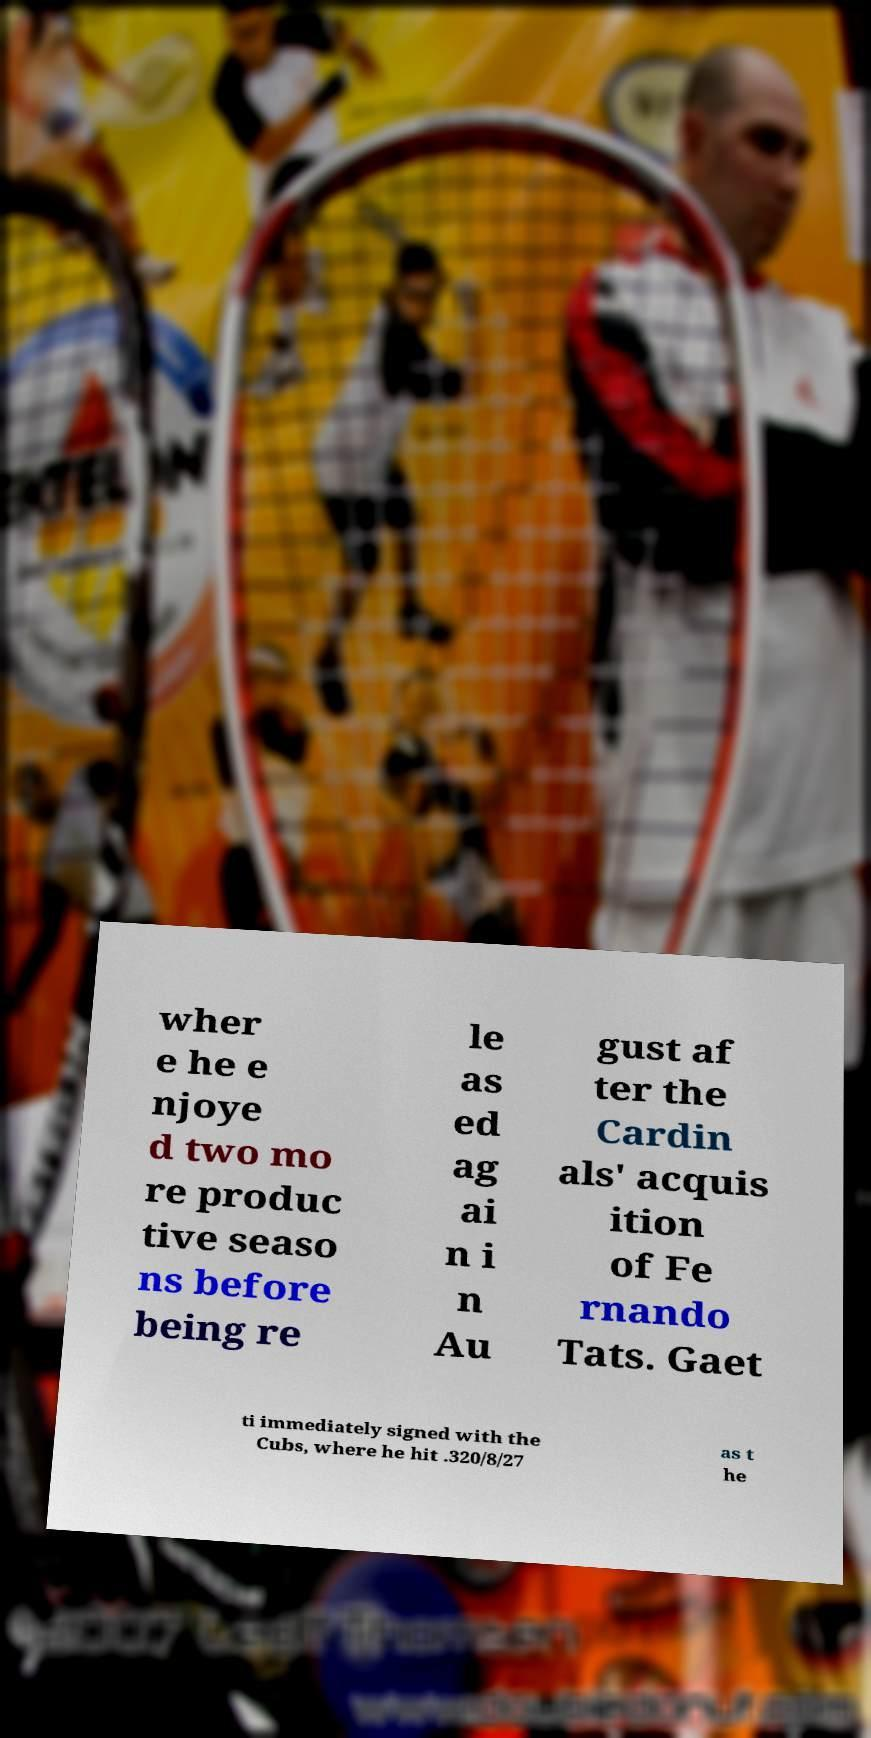Could you extract and type out the text from this image? wher e he e njoye d two mo re produc tive seaso ns before being re le as ed ag ai n i n Au gust af ter the Cardin als' acquis ition of Fe rnando Tats. Gaet ti immediately signed with the Cubs, where he hit .320/8/27 as t he 